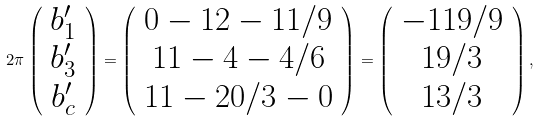Convert formula to latex. <formula><loc_0><loc_0><loc_500><loc_500>2 \pi \left ( \begin{array} { c } b _ { 1 } ^ { \prime } \\ b _ { 3 } ^ { \prime } \\ b _ { c } ^ { \prime } \end{array} \right ) = \left ( \begin{array} { c } 0 - 1 2 - 1 1 / 9 \\ 1 1 - 4 - 4 / 6 \\ 1 1 - 2 0 / 3 - 0 \end{array} \right ) = \left ( \begin{array} { c } - 1 1 9 / 9 \\ 1 9 / 3 \\ 1 3 / 3 \end{array} \right ) ,</formula> 